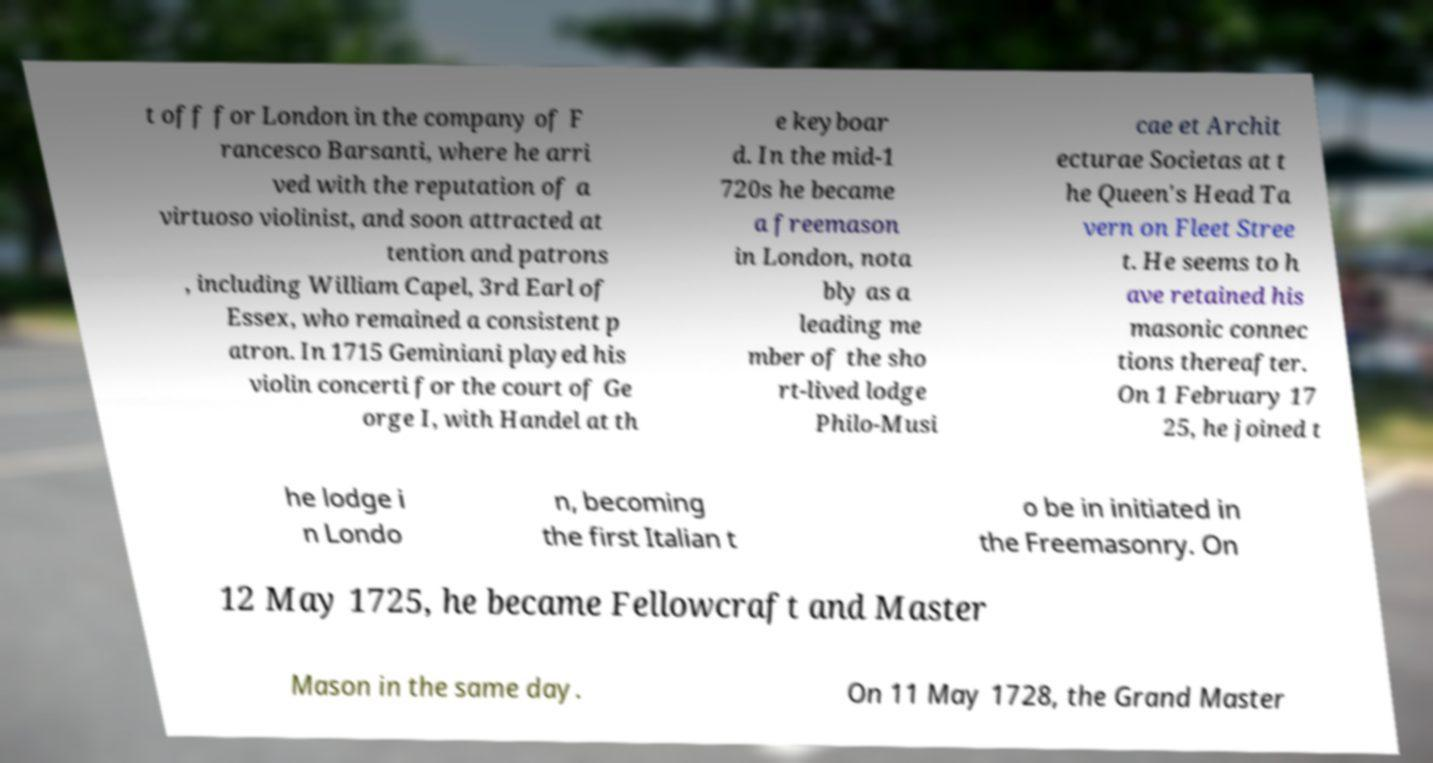Please read and relay the text visible in this image. What does it say? t off for London in the company of F rancesco Barsanti, where he arri ved with the reputation of a virtuoso violinist, and soon attracted at tention and patrons , including William Capel, 3rd Earl of Essex, who remained a consistent p atron. In 1715 Geminiani played his violin concerti for the court of Ge orge I, with Handel at th e keyboar d. In the mid-1 720s he became a freemason in London, nota bly as a leading me mber of the sho rt-lived lodge Philo-Musi cae et Archit ecturae Societas at t he Queen's Head Ta vern on Fleet Stree t. He seems to h ave retained his masonic connec tions thereafter. On 1 February 17 25, he joined t he lodge i n Londo n, becoming the first Italian t o be in initiated in the Freemasonry. On 12 May 1725, he became Fellowcraft and Master Mason in the same day. On 11 May 1728, the Grand Master 